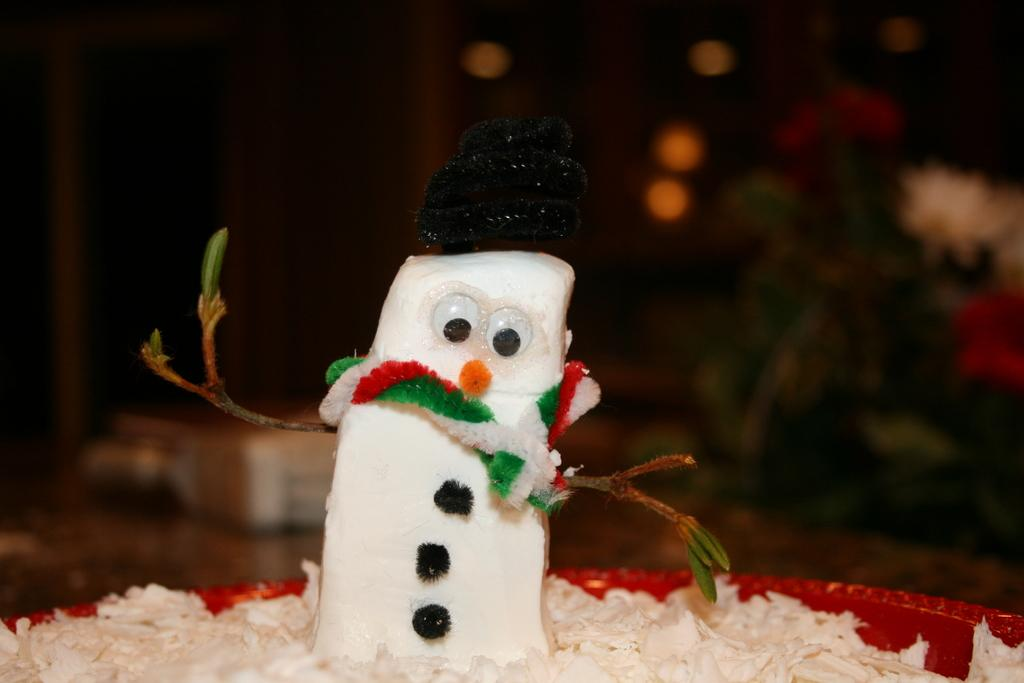What type of object is in the image? There is a toy in the image. Can you describe the toy? The toy resembles a snowman. What can be observed about the background of the image? The background of the image is blurred. Can you see a baseball game happening in the background of the image? There is no baseball game or any reference to sports in the image; it features a toy that resembles a snowman with a blurred background. 